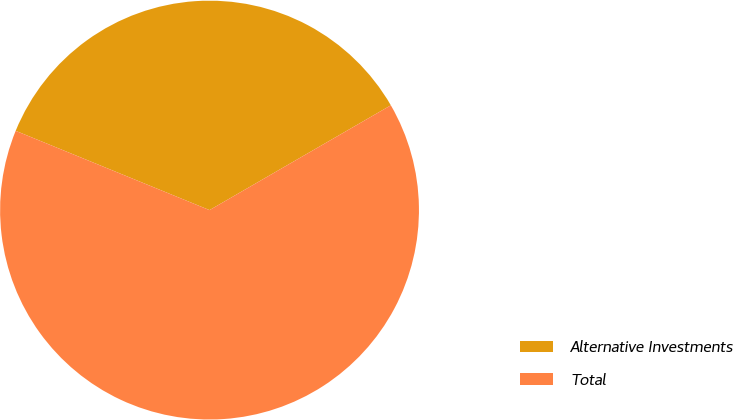Convert chart to OTSL. <chart><loc_0><loc_0><loc_500><loc_500><pie_chart><fcel>Alternative Investments<fcel>Total<nl><fcel>35.48%<fcel>64.52%<nl></chart> 